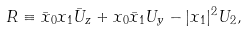Convert formula to latex. <formula><loc_0><loc_0><loc_500><loc_500>R \equiv \bar { x } _ { 0 } x _ { 1 } \bar { U } _ { z } + x _ { 0 } \bar { x } _ { 1 } U _ { y } - | x _ { 1 } | ^ { 2 } U _ { 2 } ,</formula> 